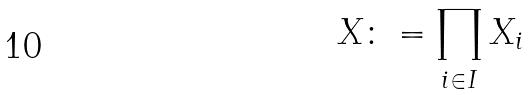<formula> <loc_0><loc_0><loc_500><loc_500>X \colon = \prod _ { i \in I } X _ { i }</formula> 